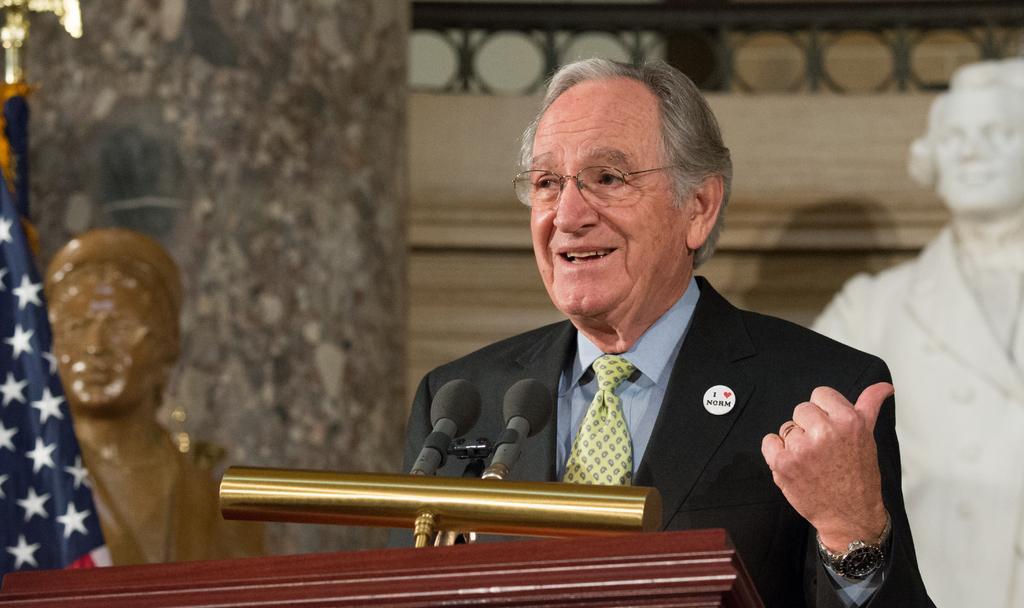How would you summarize this image in a sentence or two? In this picture, it looks like a podium and on the podium there are microphone with a stand. A man is standing behind the podium. Behind the man there are statues, a flag and the wall. Behind the flag, it looks like a pillar. 